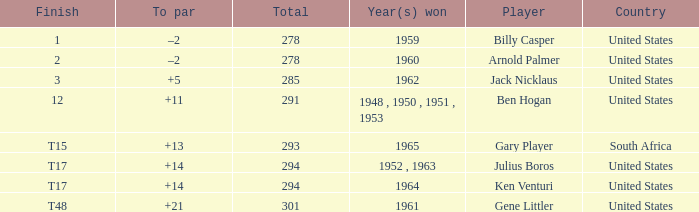What is Country, when Year(s) Won is "1962"? United States. 